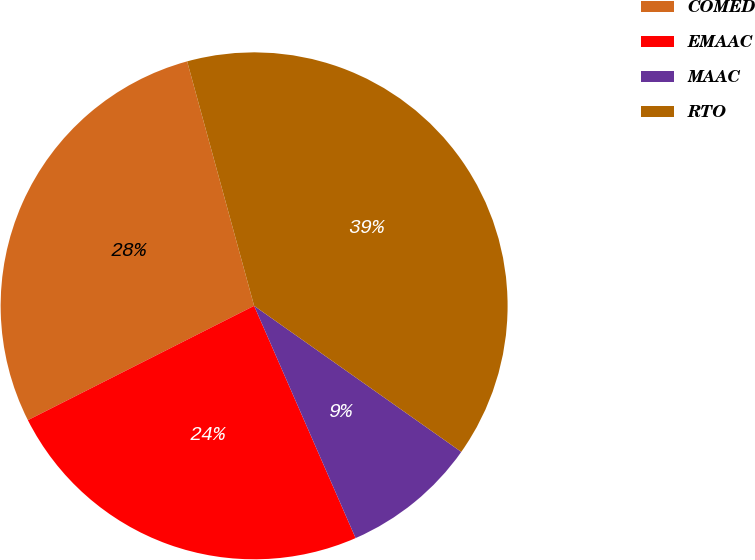Convert chart. <chart><loc_0><loc_0><loc_500><loc_500><pie_chart><fcel>COMED<fcel>EMAAC<fcel>MAAC<fcel>RTO<nl><fcel>28.19%<fcel>24.11%<fcel>8.67%<fcel>39.03%<nl></chart> 